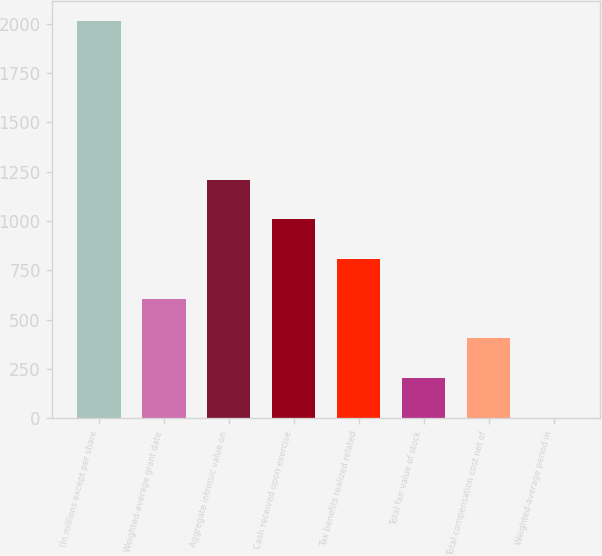Convert chart to OTSL. <chart><loc_0><loc_0><loc_500><loc_500><bar_chart><fcel>(In millions except per share<fcel>Weighted-average grant date<fcel>Aggregate intrinsic value on<fcel>Cash received upon exercise<fcel>Tax benefits realized related<fcel>Total fair value of stock<fcel>Total compensation cost net of<fcel>Weighted-average period in<nl><fcel>2015<fcel>605.9<fcel>1209.8<fcel>1008.5<fcel>807.2<fcel>203.3<fcel>404.6<fcel>2<nl></chart> 